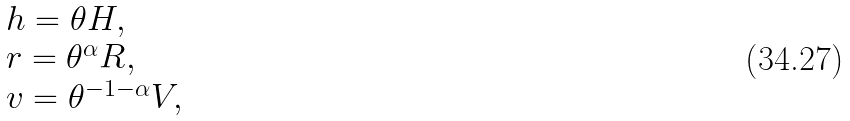Convert formula to latex. <formula><loc_0><loc_0><loc_500><loc_500>\begin{array} { l } h = \theta H , \\ r = \theta ^ { \alpha } R , \\ v = \theta ^ { - 1 - \alpha } V , \end{array}</formula> 